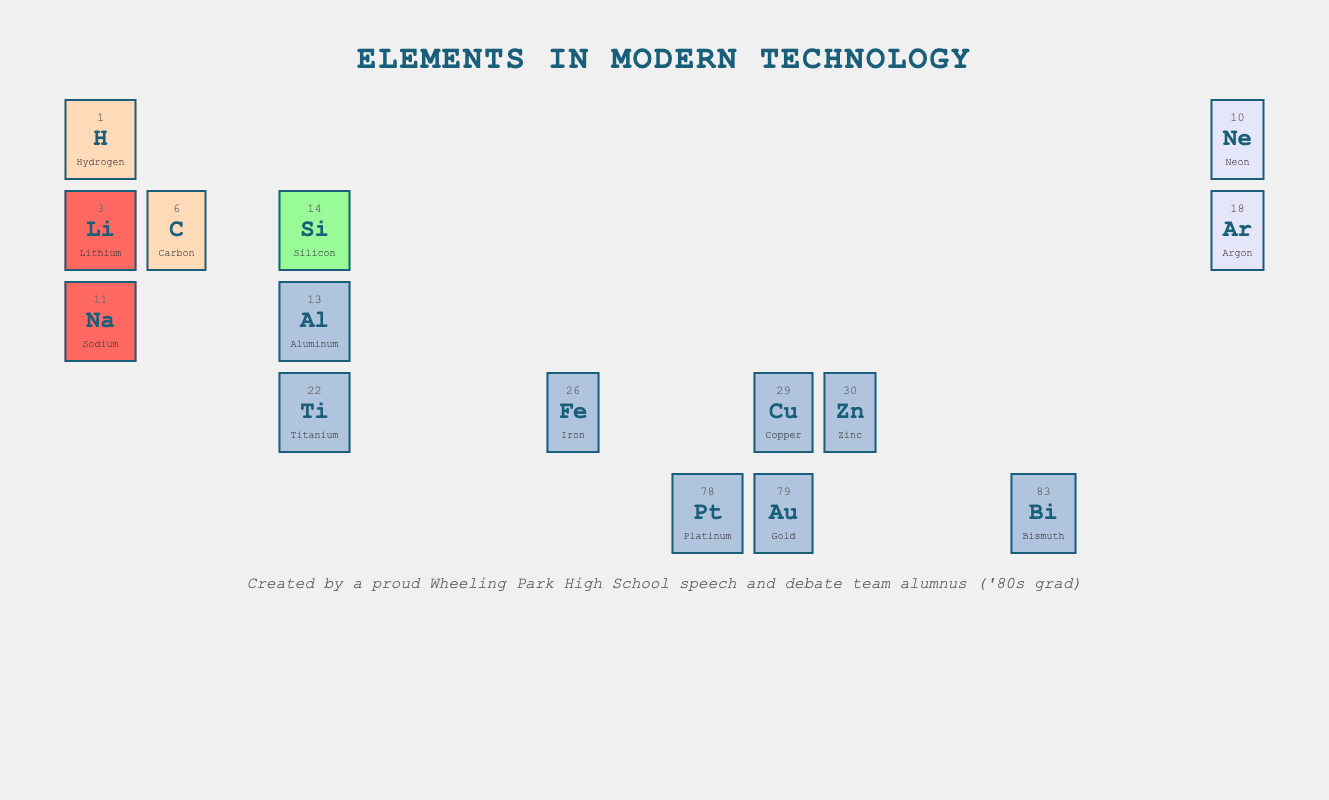What is the atomic number of Gold? The table lists Gold as an element with its atomic number shown in the corresponding cell. From the table, we can see that the atomic number for Gold is 79.
Answer: 79 Which element is used in batteries for portable devices? Referring to the application column in the table, Lithium is listed specifically for its use in batteries for portable devices, as indicated next to its name.
Answer: Lithium How many elements in the table are categorized as Noble gases? By reviewing the category of each element in the table, we find there are two Noble gases listed: Neon and Argon. Thus, we can conclude that there are two Noble gases in total.
Answer: 2 What is the sum of the atomic numbers of Iron and Copper? Looking at the table, Iron has an atomic number of 26 and Copper has an atomic number of 29. Therefore, summing these gives 26 + 29 = 55, indicating the total atomic number.
Answer: 55 Is Titanium used in aerospace components? The table identifies Titanium in the corresponding cell with its application noted as being for aerospace components due to its high strength-to-weight ratio. Therefore, the statement is true.
Answer: Yes Which element is both a metal and used in conductive materials for electronics? In the table, Gold is the only element categorized as a metal, whose application is explicitly stated as being used in conductive materials in electronics.
Answer: Gold What is the average atomic number of the three alkali metals listed? The alkali metals in the table are Lithium (3), Sodium (11), and the number for Potassium is not listed, so only these two can be calculated. To find the average, we sum these numbers: 3 + 11 = 14, and divide by the number of alkali metals (2), giving us 14 / 2 = 7.
Answer: 7 Which metal has an application in galvanization and what is its atomic number? From the application section, Zinc is identified with its application listed as galvanization in protecting steel structures. Looking further, its atomic number is noted as 30 in the table.
Answer: 30 Are there any non-metals in the table that are used for clean energy solutions? Hydrogen is categorized as a non-metal in the table and is specifically mentioned for its application in fuel cells for clean energy solutions. Thus, there is indeed a non-metal used for this purpose.
Answer: Yes 